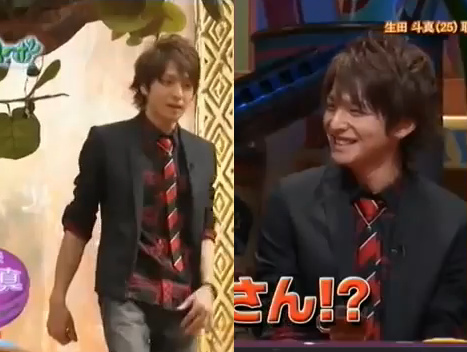Could this scene be taking place in an office? It's unlikely that this scene is taking place in an office. The background, the attire, and the expressions all suggest a more engaging and dynamic setting such as a television studio or a public event. 